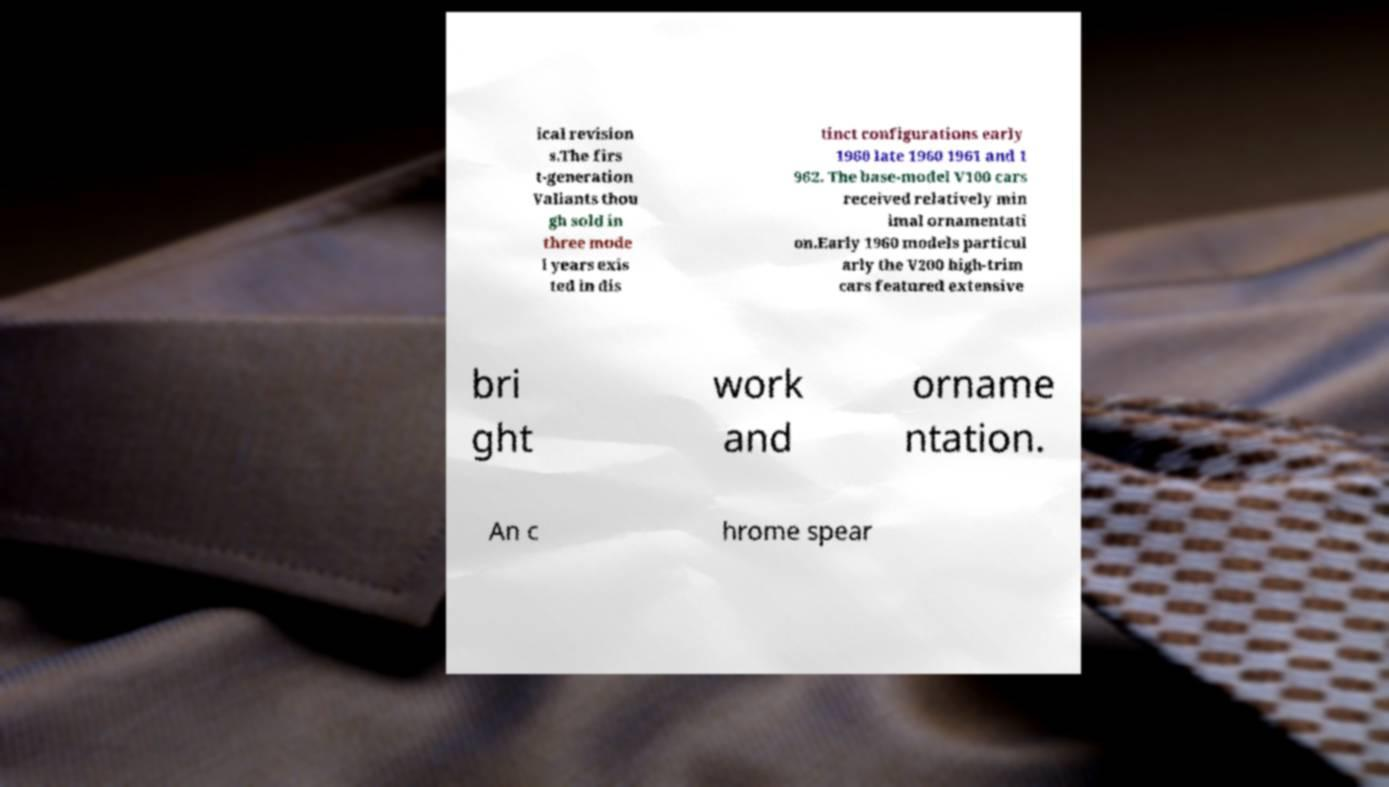Can you accurately transcribe the text from the provided image for me? ical revision s.The firs t-generation Valiants thou gh sold in three mode l years exis ted in dis tinct configurations early 1960 late 1960 1961 and 1 962. The base-model V100 cars received relatively min imal ornamentati on.Early 1960 models particul arly the V200 high-trim cars featured extensive bri ght work and orname ntation. An c hrome spear 